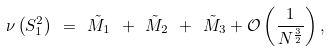<formula> <loc_0><loc_0><loc_500><loc_500>\nu \left ( S _ { 1 } ^ { 2 } \right ) \ = \ \tilde { M } _ { 1 } \ + \ \tilde { M } _ { 2 } \ + \ \tilde { M } _ { 3 } + \mathcal { O } \left ( \frac { 1 } { N ^ { \frac { 3 } { 2 } } } \right ) ,</formula> 